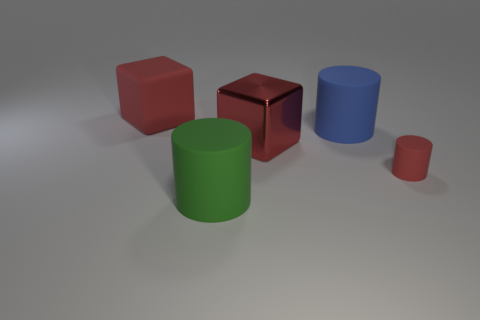Does the small object in front of the large blue rubber cylinder have the same material as the large green cylinder?
Offer a very short reply. Yes. The shiny object is what shape?
Your answer should be very brief. Cube. How many gray objects are either matte cylinders or big objects?
Keep it short and to the point. 0. How many other things are there of the same material as the blue thing?
Provide a succinct answer. 3. There is a rubber object on the left side of the large green cylinder; is its shape the same as the green thing?
Keep it short and to the point. No. Are there any yellow matte blocks?
Offer a terse response. No. Are there any other things that are the same shape as the large blue thing?
Give a very brief answer. Yes. Are there more tiny red rubber objects on the left side of the blue matte object than big cubes?
Your answer should be compact. No. Are there any red rubber objects behind the red shiny object?
Your response must be concise. Yes. Do the green rubber object and the red rubber block have the same size?
Offer a very short reply. Yes. 